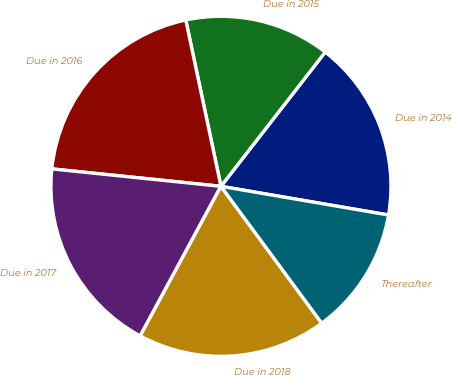Convert chart. <chart><loc_0><loc_0><loc_500><loc_500><pie_chart><fcel>Due in 2014<fcel>Due in 2015<fcel>Due in 2016<fcel>Due in 2017<fcel>Due in 2018<fcel>Thereafter<nl><fcel>17.19%<fcel>13.83%<fcel>20.05%<fcel>18.76%<fcel>17.98%<fcel>12.2%<nl></chart> 